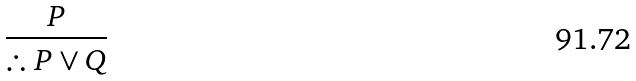<formula> <loc_0><loc_0><loc_500><loc_500>\frac { P } { \therefore P \lor Q }</formula> 